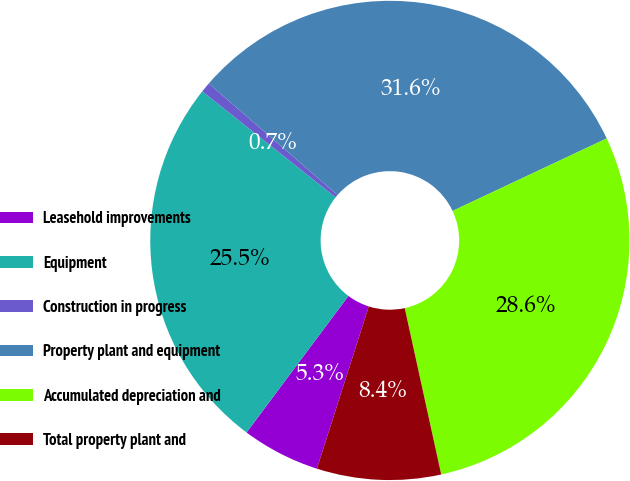<chart> <loc_0><loc_0><loc_500><loc_500><pie_chart><fcel>Leasehold improvements<fcel>Equipment<fcel>Construction in progress<fcel>Property plant and equipment<fcel>Accumulated depreciation and<fcel>Total property plant and<nl><fcel>5.28%<fcel>25.48%<fcel>0.68%<fcel>31.64%<fcel>28.56%<fcel>8.36%<nl></chart> 